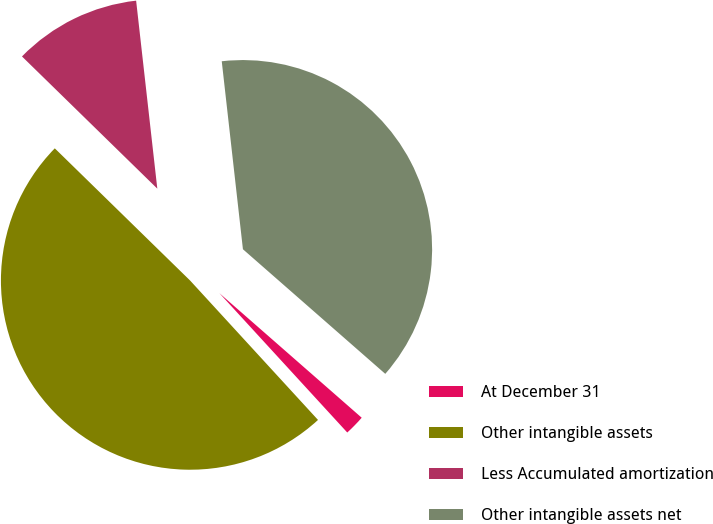Convert chart. <chart><loc_0><loc_0><loc_500><loc_500><pie_chart><fcel>At December 31<fcel>Other intangible assets<fcel>Less Accumulated amortization<fcel>Other intangible assets net<nl><fcel>1.74%<fcel>49.13%<fcel>10.9%<fcel>38.23%<nl></chart> 